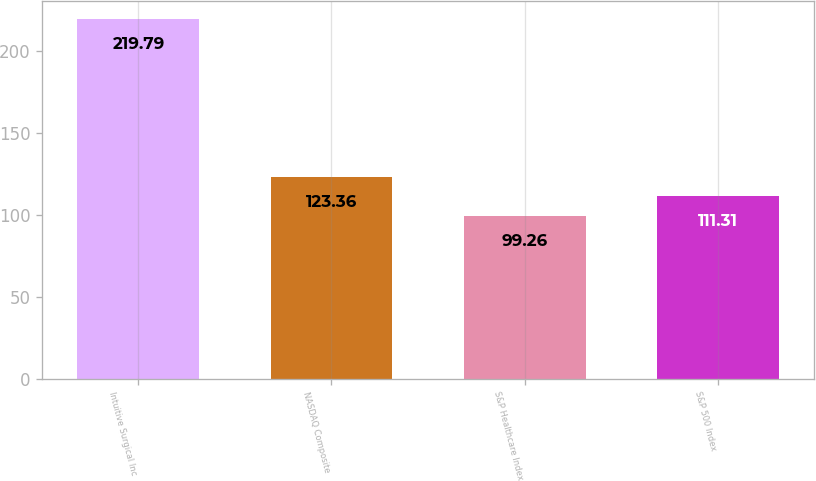<chart> <loc_0><loc_0><loc_500><loc_500><bar_chart><fcel>Intuitive Surgical Inc<fcel>NASDAQ Composite<fcel>S&P Healthcare Index<fcel>S&P 500 Index<nl><fcel>219.79<fcel>123.36<fcel>99.26<fcel>111.31<nl></chart> 